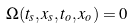Convert formula to latex. <formula><loc_0><loc_0><loc_500><loc_500>\Omega ( t _ { s } , { x } _ { s } , t _ { o } , { x } _ { o } ) = 0</formula> 